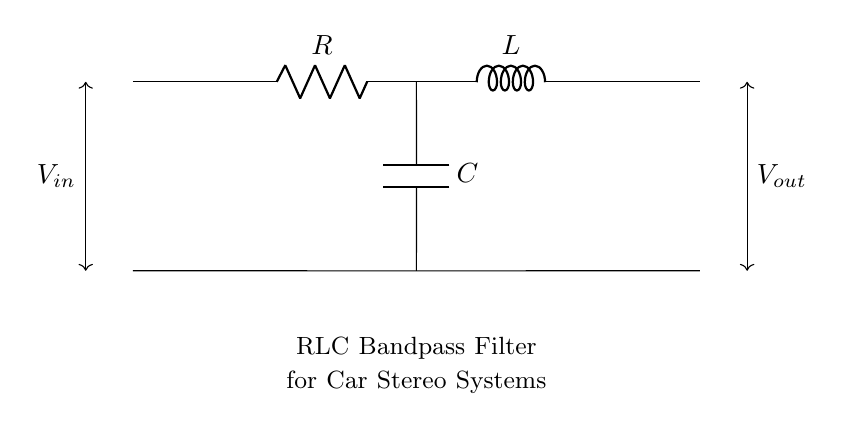What types of components are in this circuit? The circuit includes a resistor, an inductor, and a capacitor, which are the fundamental components of an RLC circuit. Each of these components plays a specific role in filtering signals in the car stereo system.
Answer: resistor, inductor, capacitor What is the output voltage denoted as? The output voltage is indicated as V out. This voltage represents the potential difference at the output of the RLC bandpass filter, which aims to transmit certain frequencies while attenuating others.
Answer: V out What is the function of the inductor in this setup? The inductor's primary role in an RLC circuit is to store energy in a magnetic field and regulate the flow of current. It contributes to the filtering functionality by allowing certain frequencies to pass through while blocking others, essential for tuning the stereo system.
Answer: store energy What happens to frequencies outside the passband? Frequencies outside the passband will be attenuated significantly. This is due to the properties of the RLC circuit, which allows it to resonate at specific frequencies while rejecting those that are higher or lower than its design specifications.
Answer: attenuated What is the main purpose of this RLC circuit? The main purpose of this RLC circuit is to create a bandpass filter that enhances audio signal quality in a car stereo system by allowing a specific range of frequencies to pass while blocking others. This results in improved sound performance for music playback.
Answer: bandpass filter How does changing the values of R, L, or C affect the filter? Changing the values of R, L, or C alters the cutoff frequencies and the bandwidth of the filter. The resistance affects the damping of the circuit, while the inductance and capacitance determine the resonant frequency, impacting which frequencies are amplified or attenuated.
Answer: alters cutoff frequencies 